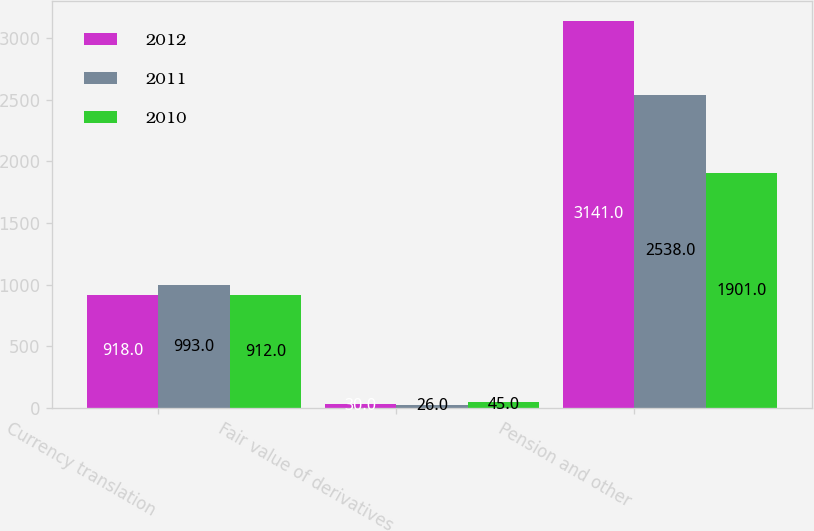Convert chart. <chart><loc_0><loc_0><loc_500><loc_500><stacked_bar_chart><ecel><fcel>Currency translation<fcel>Fair value of derivatives<fcel>Pension and other<nl><fcel>2012<fcel>918<fcel>30<fcel>3141<nl><fcel>2011<fcel>993<fcel>26<fcel>2538<nl><fcel>2010<fcel>912<fcel>45<fcel>1901<nl></chart> 